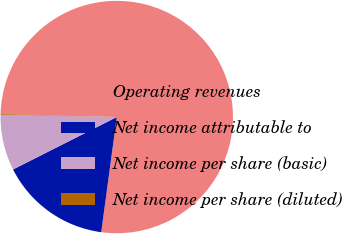Convert chart to OTSL. <chart><loc_0><loc_0><loc_500><loc_500><pie_chart><fcel>Operating revenues<fcel>Net income attributable to<fcel>Net income per share (basic)<fcel>Net income per share (diluted)<nl><fcel>76.72%<fcel>15.42%<fcel>7.76%<fcel>0.1%<nl></chart> 